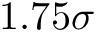Convert formula to latex. <formula><loc_0><loc_0><loc_500><loc_500>1 . 7 5 \sigma</formula> 